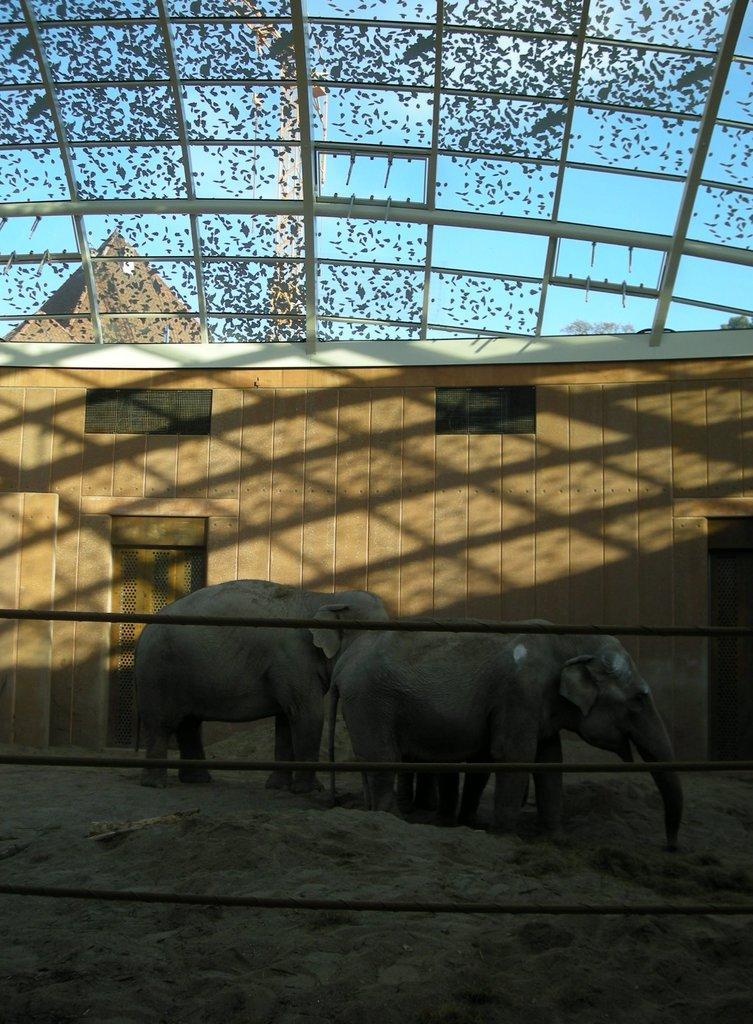Can you describe this image briefly? In this picture we can see rods, elephants on the ground, shed and some objects and in the background we can see the sky. 